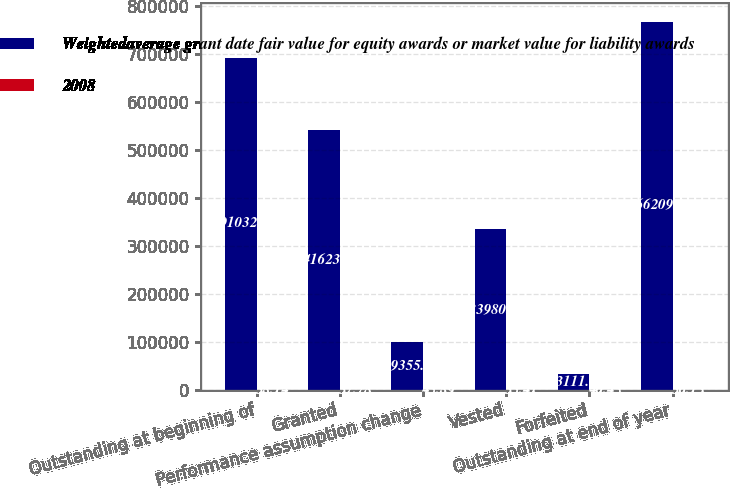Convert chart to OTSL. <chart><loc_0><loc_0><loc_500><loc_500><stacked_bar_chart><ecel><fcel>Outstanding at beginning of<fcel>Granted<fcel>Performance assumption change<fcel>Vested<fcel>Forfeited<fcel>Outstanding at end of year<nl><fcel>Weightedaverage grant date fair value for equity awards or market value for liability awards<fcel>691032<fcel>541623<fcel>99355<fcel>333980<fcel>33111<fcel>766209<nl><fcel>2008<fcel>38.14<fcel>37.78<fcel>45.89<fcel>35.41<fcel>40.45<fcel>36.13<nl></chart> 